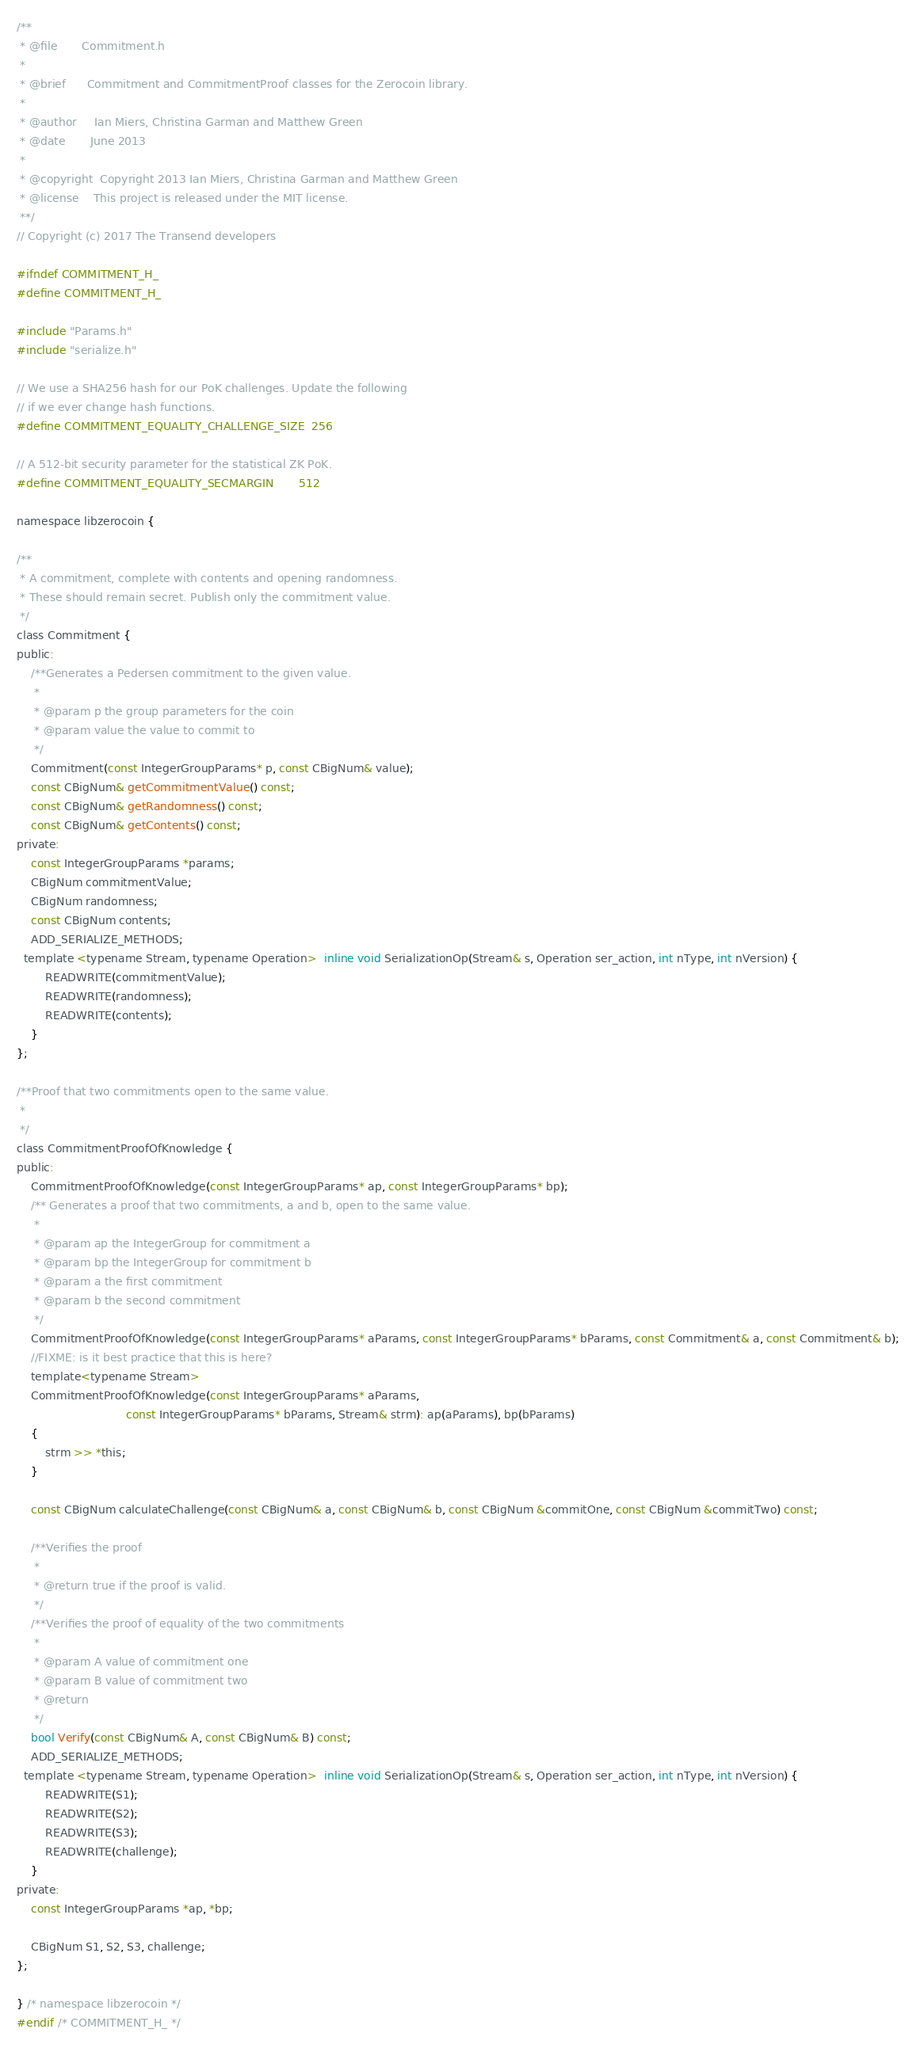Convert code to text. <code><loc_0><loc_0><loc_500><loc_500><_C_>/**
 * @file       Commitment.h
 *
 * @brief      Commitment and CommitmentProof classes for the Zerocoin library.
 *
 * @author     Ian Miers, Christina Garman and Matthew Green
 * @date       June 2013
 *
 * @copyright  Copyright 2013 Ian Miers, Christina Garman and Matthew Green
 * @license    This project is released under the MIT license.
 **/
// Copyright (c) 2017 The Transend developers

#ifndef COMMITMENT_H_
#define COMMITMENT_H_

#include "Params.h"
#include "serialize.h"

// We use a SHA256 hash for our PoK challenges. Update the following
// if we ever change hash functions.
#define COMMITMENT_EQUALITY_CHALLENGE_SIZE  256

// A 512-bit security parameter for the statistical ZK PoK.
#define COMMITMENT_EQUALITY_SECMARGIN       512

namespace libzerocoin {

/**
 * A commitment, complete with contents and opening randomness.
 * These should remain secret. Publish only the commitment value.
 */
class Commitment {
public:
	/**Generates a Pedersen commitment to the given value.
	 *
	 * @param p the group parameters for the coin
	 * @param value the value to commit to
	 */
	Commitment(const IntegerGroupParams* p, const CBigNum& value);
	const CBigNum& getCommitmentValue() const;
	const CBigNum& getRandomness() const;
	const CBigNum& getContents() const;
private:
	const IntegerGroupParams *params;
	CBigNum commitmentValue;
	CBigNum randomness;
	const CBigNum contents;
	ADD_SERIALIZE_METHODS;
  template <typename Stream, typename Operation>  inline void SerializationOp(Stream& s, Operation ser_action, int nType, int nVersion) {
	    READWRITE(commitmentValue);
	    READWRITE(randomness);
	    READWRITE(contents);
	}
};

/**Proof that two commitments open to the same value.
 *
 */
class CommitmentProofOfKnowledge {
public:
	CommitmentProofOfKnowledge(const IntegerGroupParams* ap, const IntegerGroupParams* bp);
	/** Generates a proof that two commitments, a and b, open to the same value.
	 *
	 * @param ap the IntegerGroup for commitment a
	 * @param bp the IntegerGroup for commitment b
	 * @param a the first commitment
	 * @param b the second commitment
	 */
	CommitmentProofOfKnowledge(const IntegerGroupParams* aParams, const IntegerGroupParams* bParams, const Commitment& a, const Commitment& b);
	//FIXME: is it best practice that this is here?
	template<typename Stream>
	CommitmentProofOfKnowledge(const IntegerGroupParams* aParams,
	                           const IntegerGroupParams* bParams, Stream& strm): ap(aParams), bp(bParams)
	{
		strm >> *this;
	}

	const CBigNum calculateChallenge(const CBigNum& a, const CBigNum& b, const CBigNum &commitOne, const CBigNum &commitTwo) const;

	/**Verifies the proof
	 *
	 * @return true if the proof is valid.
	 */
	/**Verifies the proof of equality of the two commitments
	 *
	 * @param A value of commitment one
	 * @param B value of commitment two
	 * @return
	 */
	bool Verify(const CBigNum& A, const CBigNum& B) const;
	ADD_SERIALIZE_METHODS;
  template <typename Stream, typename Operation>  inline void SerializationOp(Stream& s, Operation ser_action, int nType, int nVersion) {
	    READWRITE(S1);
	    READWRITE(S2);
	    READWRITE(S3);
	    READWRITE(challenge);
	}
private:
	const IntegerGroupParams *ap, *bp;

	CBigNum S1, S2, S3, challenge;
};

} /* namespace libzerocoin */
#endif /* COMMITMENT_H_ */
</code> 